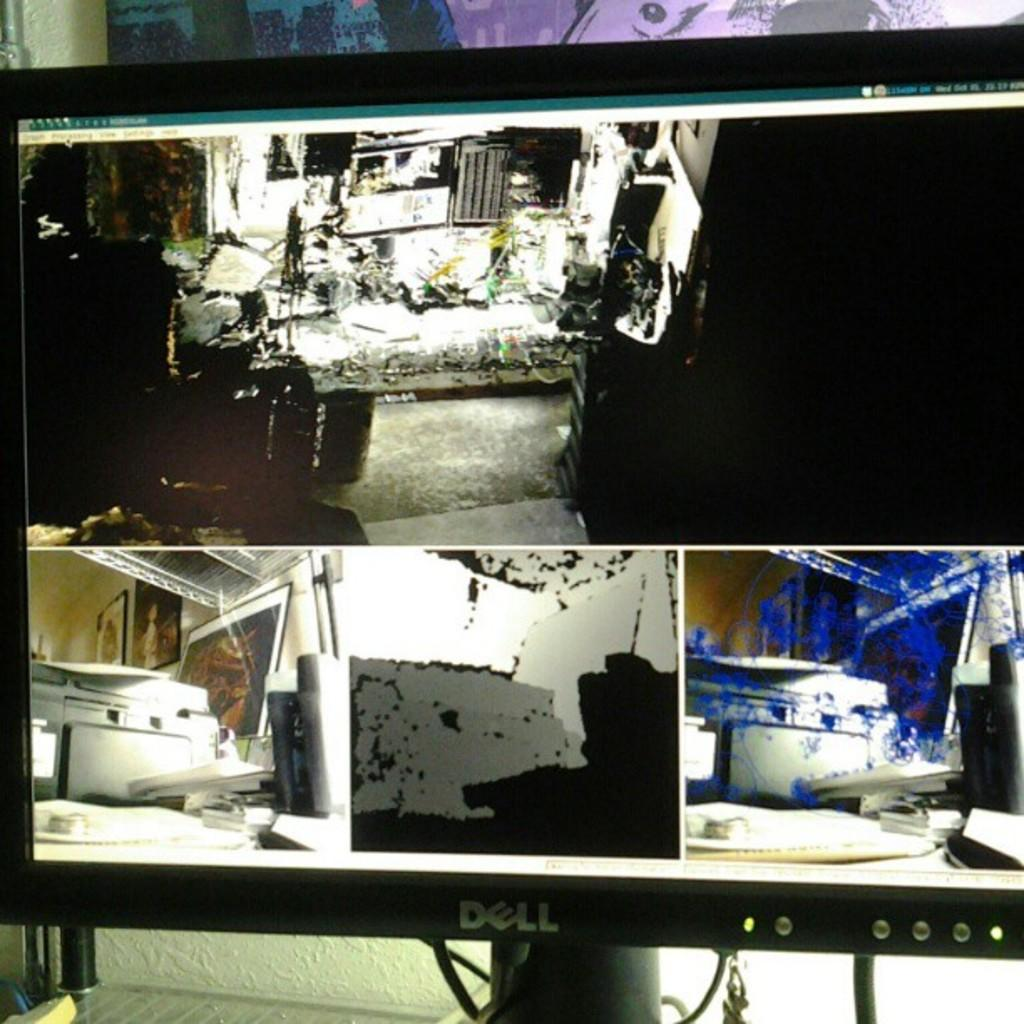<image>
Share a concise interpretation of the image provided. A Dell computer monitor shows four different edited pictures. 